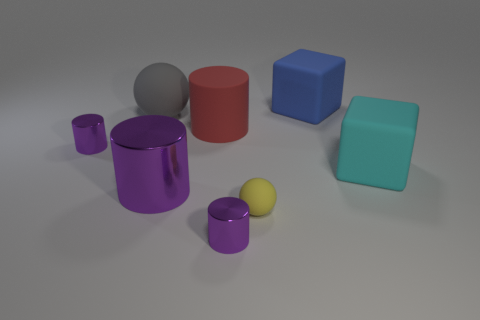Add 1 tiny metal blocks. How many objects exist? 9 Subtract all big matte cylinders. How many cylinders are left? 3 Subtract all yellow balls. How many balls are left? 1 Subtract all gray blocks. How many yellow cylinders are left? 0 Subtract 1 cyan cubes. How many objects are left? 7 Subtract all balls. How many objects are left? 6 Subtract 1 spheres. How many spheres are left? 1 Subtract all purple cylinders. Subtract all blue spheres. How many cylinders are left? 1 Subtract all large purple metal cubes. Subtract all red objects. How many objects are left? 7 Add 1 big rubber cubes. How many big rubber cubes are left? 3 